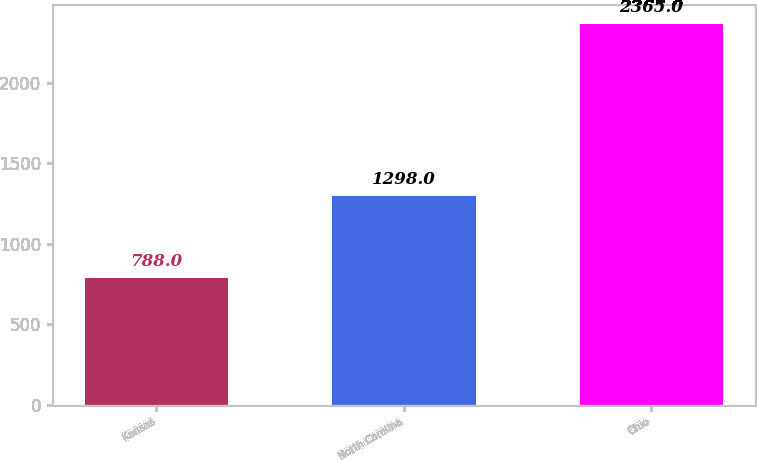Convert chart. <chart><loc_0><loc_0><loc_500><loc_500><bar_chart><fcel>Kansas<fcel>North Carolina<fcel>Ohio<nl><fcel>788<fcel>1298<fcel>2365<nl></chart> 